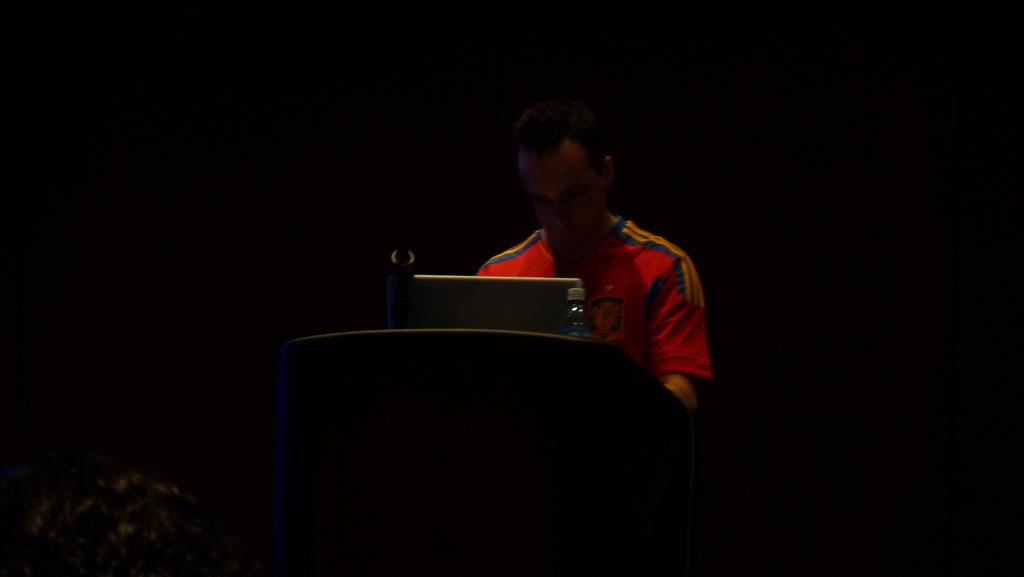Who is the main subject in the image? There is a man in the image. What is the man doing in the image? The man is standing in front of a podium. What objects are on the podium? There is a laptop and a bottle on the podium. What type of disgusting beast can be seen in the image? There is no disgusting beast present in the image; it features a man standing in front of a podium with a laptop and a bottle. How many chickens are visible in the image? There are no chickens present in the image. 